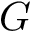<formula> <loc_0><loc_0><loc_500><loc_500>G</formula> 